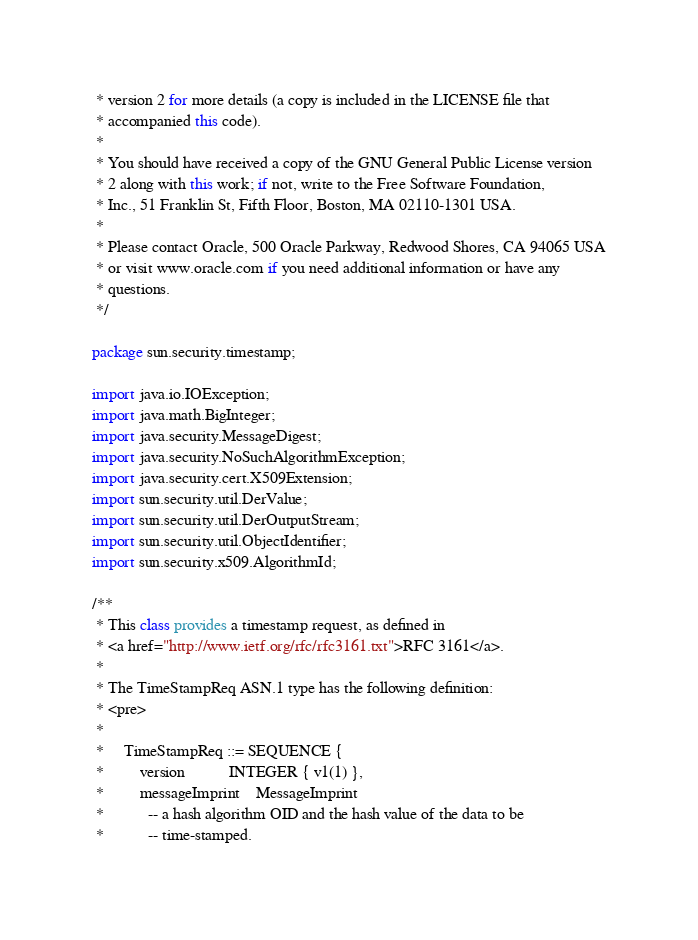<code> <loc_0><loc_0><loc_500><loc_500><_Java_> * version 2 for more details (a copy is included in the LICENSE file that
 * accompanied this code).
 *
 * You should have received a copy of the GNU General Public License version
 * 2 along with this work; if not, write to the Free Software Foundation,
 * Inc., 51 Franklin St, Fifth Floor, Boston, MA 02110-1301 USA.
 *
 * Please contact Oracle, 500 Oracle Parkway, Redwood Shores, CA 94065 USA
 * or visit www.oracle.com if you need additional information or have any
 * questions.
 */

package sun.security.timestamp;

import java.io.IOException;
import java.math.BigInteger;
import java.security.MessageDigest;
import java.security.NoSuchAlgorithmException;
import java.security.cert.X509Extension;
import sun.security.util.DerValue;
import sun.security.util.DerOutputStream;
import sun.security.util.ObjectIdentifier;
import sun.security.x509.AlgorithmId;

/**
 * This class provides a timestamp request, as defined in
 * <a href="http://www.ietf.org/rfc/rfc3161.txt">RFC 3161</a>.
 *
 * The TimeStampReq ASN.1 type has the following definition:
 * <pre>
 *
 *     TimeStampReq ::= SEQUENCE {
 *         version           INTEGER { v1(1) },
 *         messageImprint    MessageImprint
 *           -- a hash algorithm OID and the hash value of the data to be
 *           -- time-stamped.</code> 